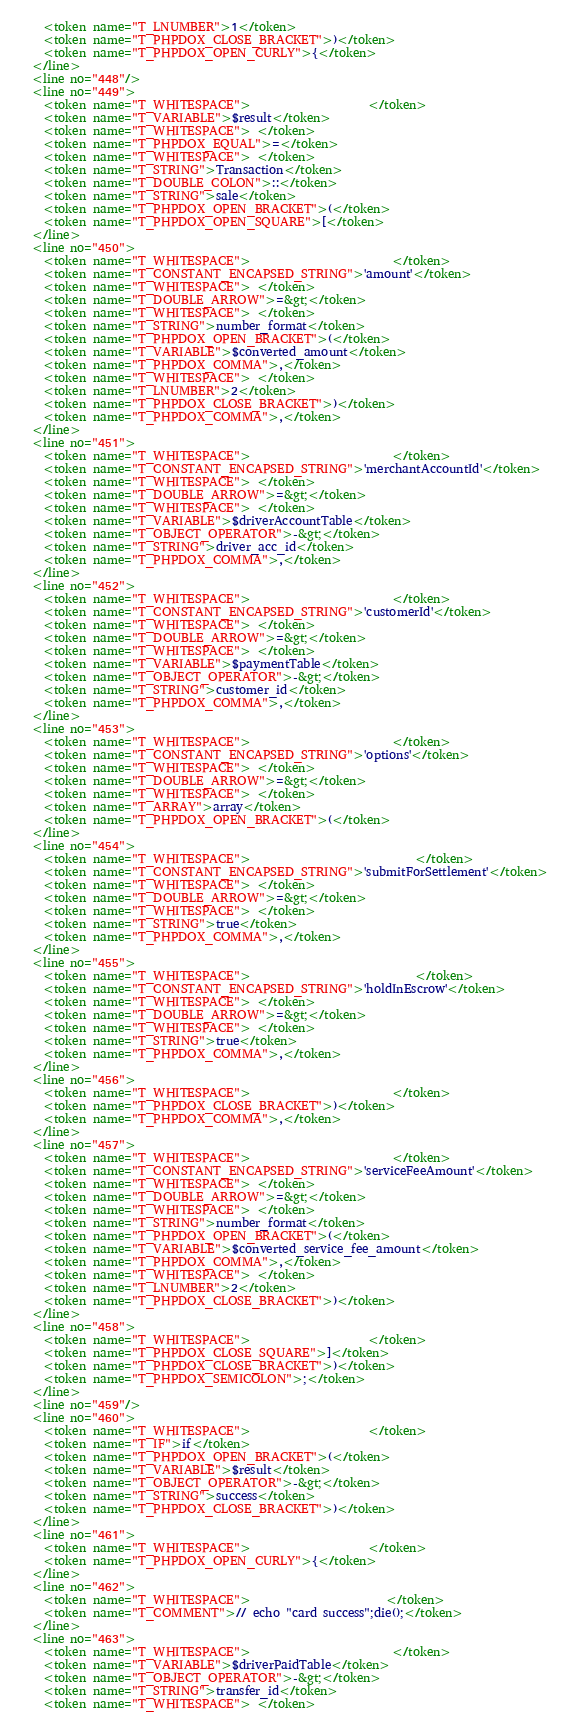<code> <loc_0><loc_0><loc_500><loc_500><_XML_>    <token name="T_LNUMBER">1</token>
    <token name="T_PHPDOX_CLOSE_BRACKET">)</token>
    <token name="T_PHPDOX_OPEN_CURLY">{</token>
  </line>
  <line no="448"/>
  <line no="449">
    <token name="T_WHITESPACE">                    </token>
    <token name="T_VARIABLE">$result</token>
    <token name="T_WHITESPACE"> </token>
    <token name="T_PHPDOX_EQUAL">=</token>
    <token name="T_WHITESPACE"> </token>
    <token name="T_STRING">Transaction</token>
    <token name="T_DOUBLE_COLON">::</token>
    <token name="T_STRING">sale</token>
    <token name="T_PHPDOX_OPEN_BRACKET">(</token>
    <token name="T_PHPDOX_OPEN_SQUARE">[</token>
  </line>
  <line no="450">
    <token name="T_WHITESPACE">                        </token>
    <token name="T_CONSTANT_ENCAPSED_STRING">'amount'</token>
    <token name="T_WHITESPACE"> </token>
    <token name="T_DOUBLE_ARROW">=&gt;</token>
    <token name="T_WHITESPACE"> </token>
    <token name="T_STRING">number_format</token>
    <token name="T_PHPDOX_OPEN_BRACKET">(</token>
    <token name="T_VARIABLE">$converted_amount</token>
    <token name="T_PHPDOX_COMMA">,</token>
    <token name="T_WHITESPACE"> </token>
    <token name="T_LNUMBER">2</token>
    <token name="T_PHPDOX_CLOSE_BRACKET">)</token>
    <token name="T_PHPDOX_COMMA">,</token>
  </line>
  <line no="451">
    <token name="T_WHITESPACE">                        </token>
    <token name="T_CONSTANT_ENCAPSED_STRING">'merchantAccountId'</token>
    <token name="T_WHITESPACE"> </token>
    <token name="T_DOUBLE_ARROW">=&gt;</token>
    <token name="T_WHITESPACE"> </token>
    <token name="T_VARIABLE">$driverAccountTable</token>
    <token name="T_OBJECT_OPERATOR">-&gt;</token>
    <token name="T_STRING">driver_acc_id</token>
    <token name="T_PHPDOX_COMMA">,</token>
  </line>
  <line no="452">
    <token name="T_WHITESPACE">                        </token>
    <token name="T_CONSTANT_ENCAPSED_STRING">'customerId'</token>
    <token name="T_WHITESPACE"> </token>
    <token name="T_DOUBLE_ARROW">=&gt;</token>
    <token name="T_WHITESPACE"> </token>
    <token name="T_VARIABLE">$paymentTable</token>
    <token name="T_OBJECT_OPERATOR">-&gt;</token>
    <token name="T_STRING">customer_id</token>
    <token name="T_PHPDOX_COMMA">,</token>
  </line>
  <line no="453">
    <token name="T_WHITESPACE">                        </token>
    <token name="T_CONSTANT_ENCAPSED_STRING">'options'</token>
    <token name="T_WHITESPACE"> </token>
    <token name="T_DOUBLE_ARROW">=&gt;</token>
    <token name="T_WHITESPACE"> </token>
    <token name="T_ARRAY">array</token>
    <token name="T_PHPDOX_OPEN_BRACKET">(</token>
  </line>
  <line no="454">
    <token name="T_WHITESPACE">                            </token>
    <token name="T_CONSTANT_ENCAPSED_STRING">'submitForSettlement'</token>
    <token name="T_WHITESPACE"> </token>
    <token name="T_DOUBLE_ARROW">=&gt;</token>
    <token name="T_WHITESPACE"> </token>
    <token name="T_STRING">true</token>
    <token name="T_PHPDOX_COMMA">,</token>
  </line>
  <line no="455">
    <token name="T_WHITESPACE">                            </token>
    <token name="T_CONSTANT_ENCAPSED_STRING">'holdInEscrow'</token>
    <token name="T_WHITESPACE"> </token>
    <token name="T_DOUBLE_ARROW">=&gt;</token>
    <token name="T_WHITESPACE"> </token>
    <token name="T_STRING">true</token>
    <token name="T_PHPDOX_COMMA">,</token>
  </line>
  <line no="456">
    <token name="T_WHITESPACE">                        </token>
    <token name="T_PHPDOX_CLOSE_BRACKET">)</token>
    <token name="T_PHPDOX_COMMA">,</token>
  </line>
  <line no="457">
    <token name="T_WHITESPACE">                        </token>
    <token name="T_CONSTANT_ENCAPSED_STRING">'serviceFeeAmount'</token>
    <token name="T_WHITESPACE"> </token>
    <token name="T_DOUBLE_ARROW">=&gt;</token>
    <token name="T_WHITESPACE"> </token>
    <token name="T_STRING">number_format</token>
    <token name="T_PHPDOX_OPEN_BRACKET">(</token>
    <token name="T_VARIABLE">$converted_service_fee_amount</token>
    <token name="T_PHPDOX_COMMA">,</token>
    <token name="T_WHITESPACE"> </token>
    <token name="T_LNUMBER">2</token>
    <token name="T_PHPDOX_CLOSE_BRACKET">)</token>
  </line>
  <line no="458">
    <token name="T_WHITESPACE">                    </token>
    <token name="T_PHPDOX_CLOSE_SQUARE">]</token>
    <token name="T_PHPDOX_CLOSE_BRACKET">)</token>
    <token name="T_PHPDOX_SEMICOLON">;</token>
  </line>
  <line no="459"/>
  <line no="460">
    <token name="T_WHITESPACE">                    </token>
    <token name="T_IF">if</token>
    <token name="T_PHPDOX_OPEN_BRACKET">(</token>
    <token name="T_VARIABLE">$result</token>
    <token name="T_OBJECT_OPERATOR">-&gt;</token>
    <token name="T_STRING">success</token>
    <token name="T_PHPDOX_CLOSE_BRACKET">)</token>
  </line>
  <line no="461">
    <token name="T_WHITESPACE">                    </token>
    <token name="T_PHPDOX_OPEN_CURLY">{</token>
  </line>
  <line no="462">
    <token name="T_WHITESPACE">                       </token>
    <token name="T_COMMENT">// echo "card success";die();</token>
  </line>
  <line no="463">
    <token name="T_WHITESPACE">                        </token>
    <token name="T_VARIABLE">$driverPaidTable</token>
    <token name="T_OBJECT_OPERATOR">-&gt;</token>
    <token name="T_STRING">transfer_id</token>
    <token name="T_WHITESPACE"> </token></code> 